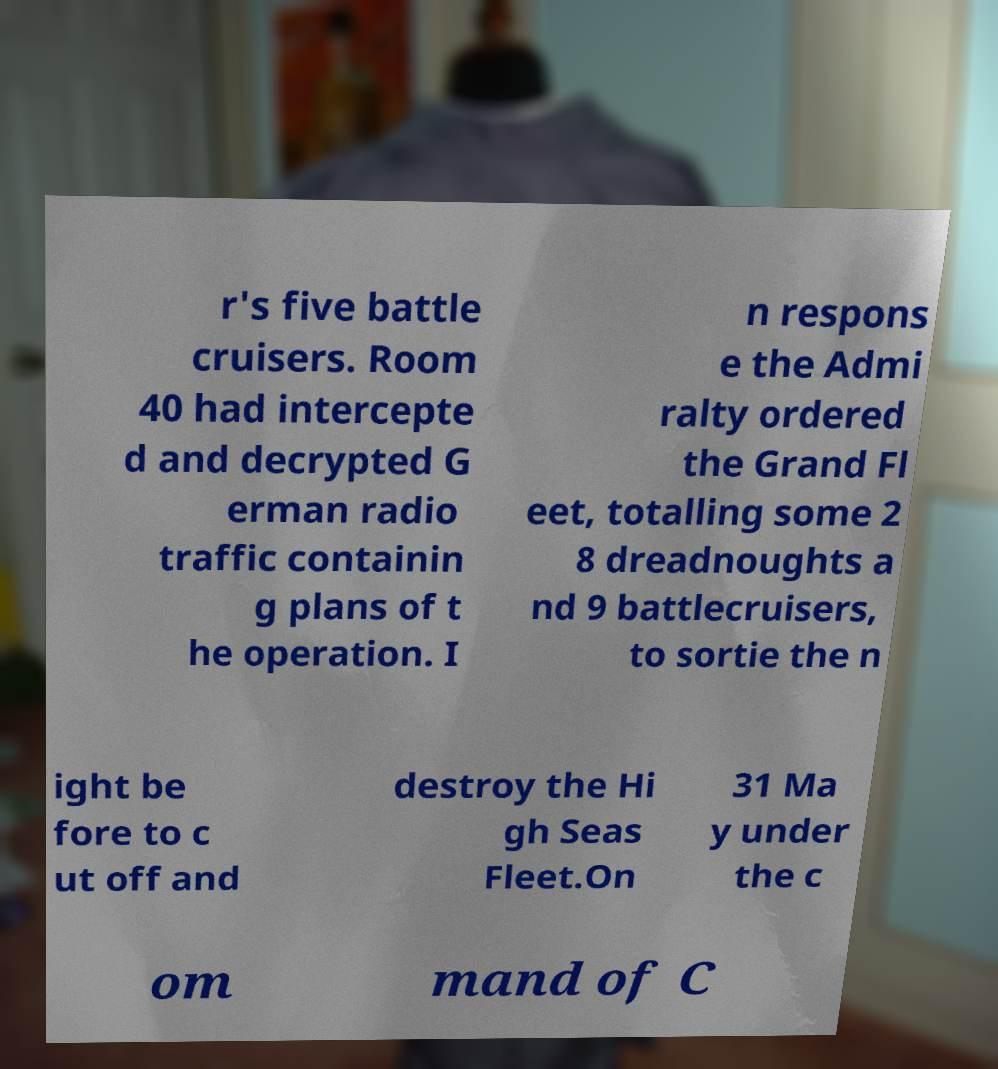Can you read and provide the text displayed in the image?This photo seems to have some interesting text. Can you extract and type it out for me? r's five battle cruisers. Room 40 had intercepte d and decrypted G erman radio traffic containin g plans of t he operation. I n respons e the Admi ralty ordered the Grand Fl eet, totalling some 2 8 dreadnoughts a nd 9 battlecruisers, to sortie the n ight be fore to c ut off and destroy the Hi gh Seas Fleet.On 31 Ma y under the c om mand of C 